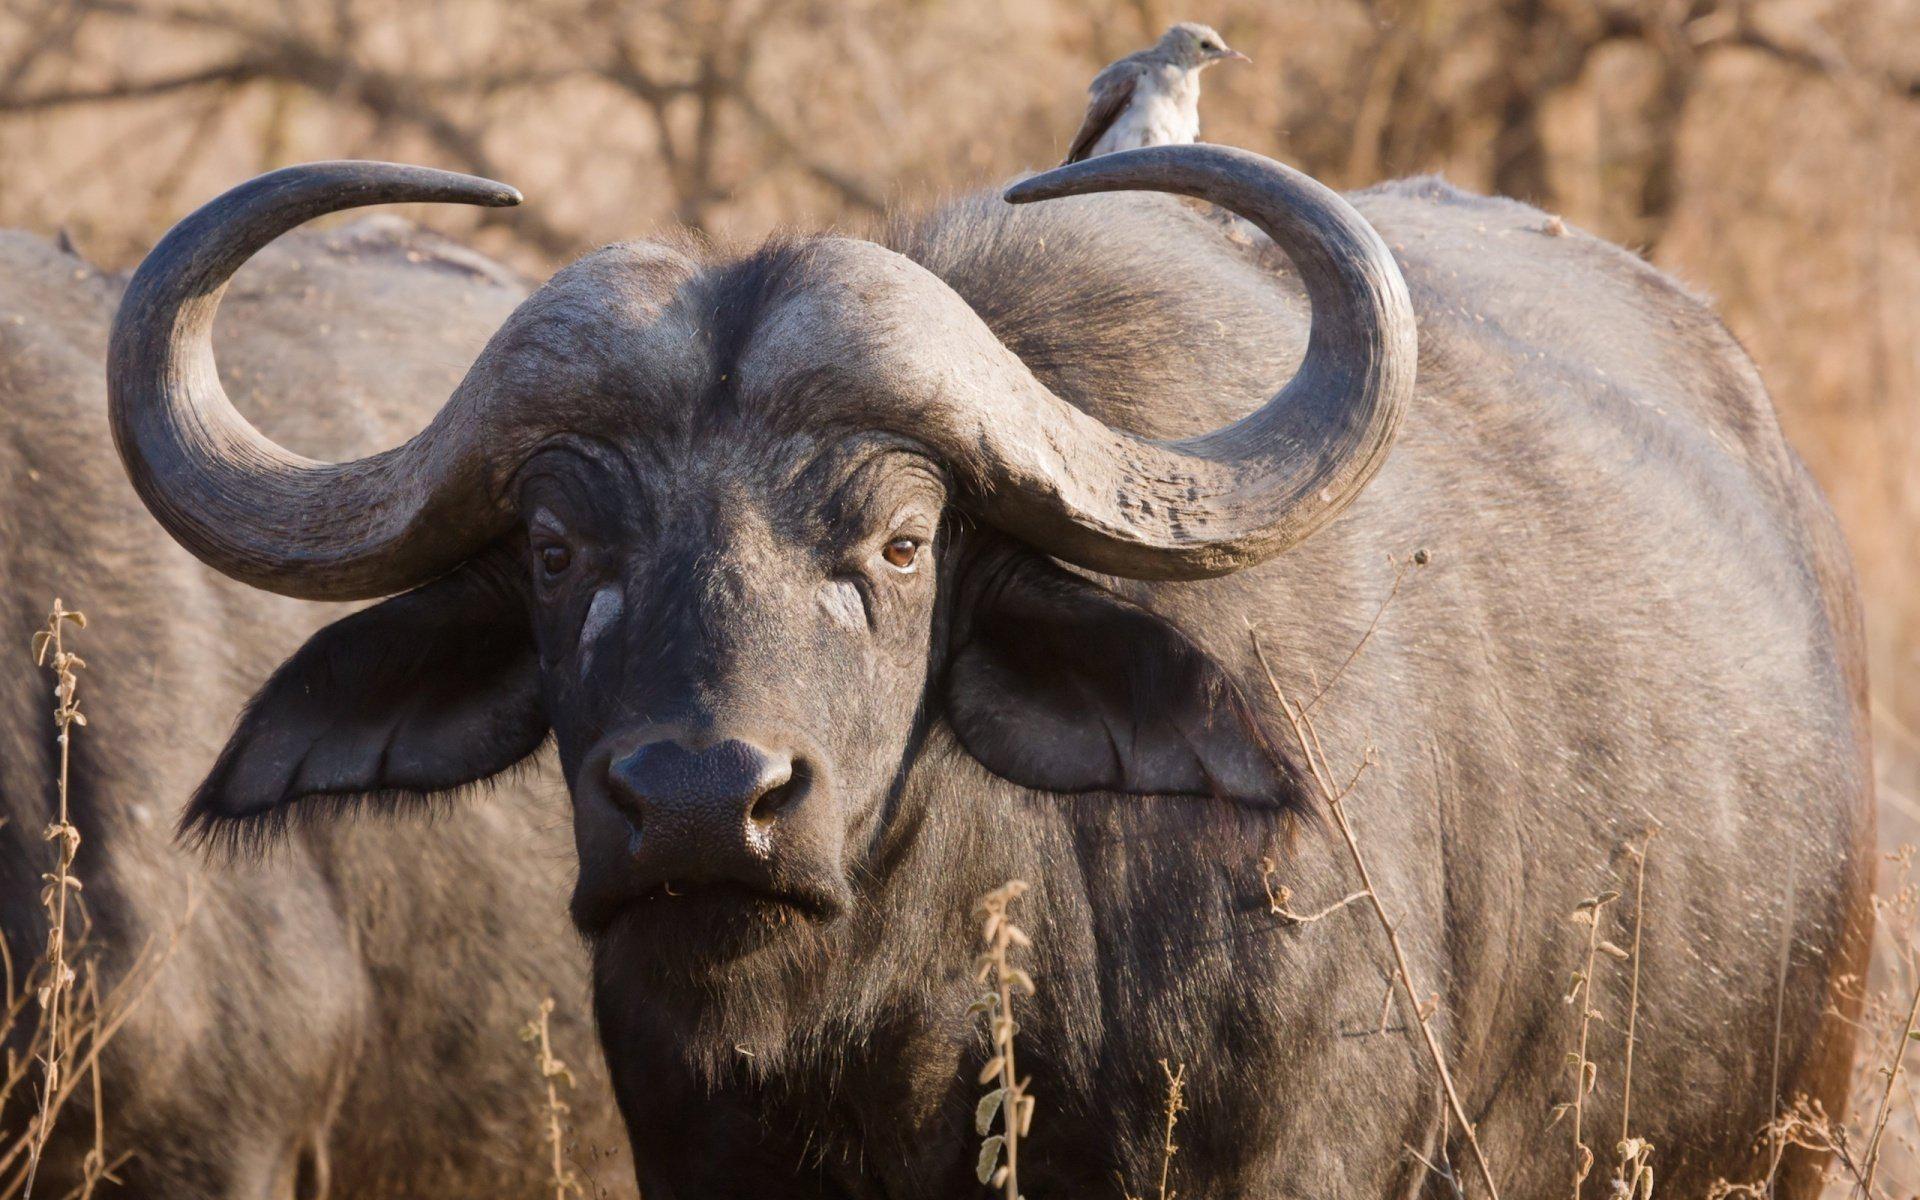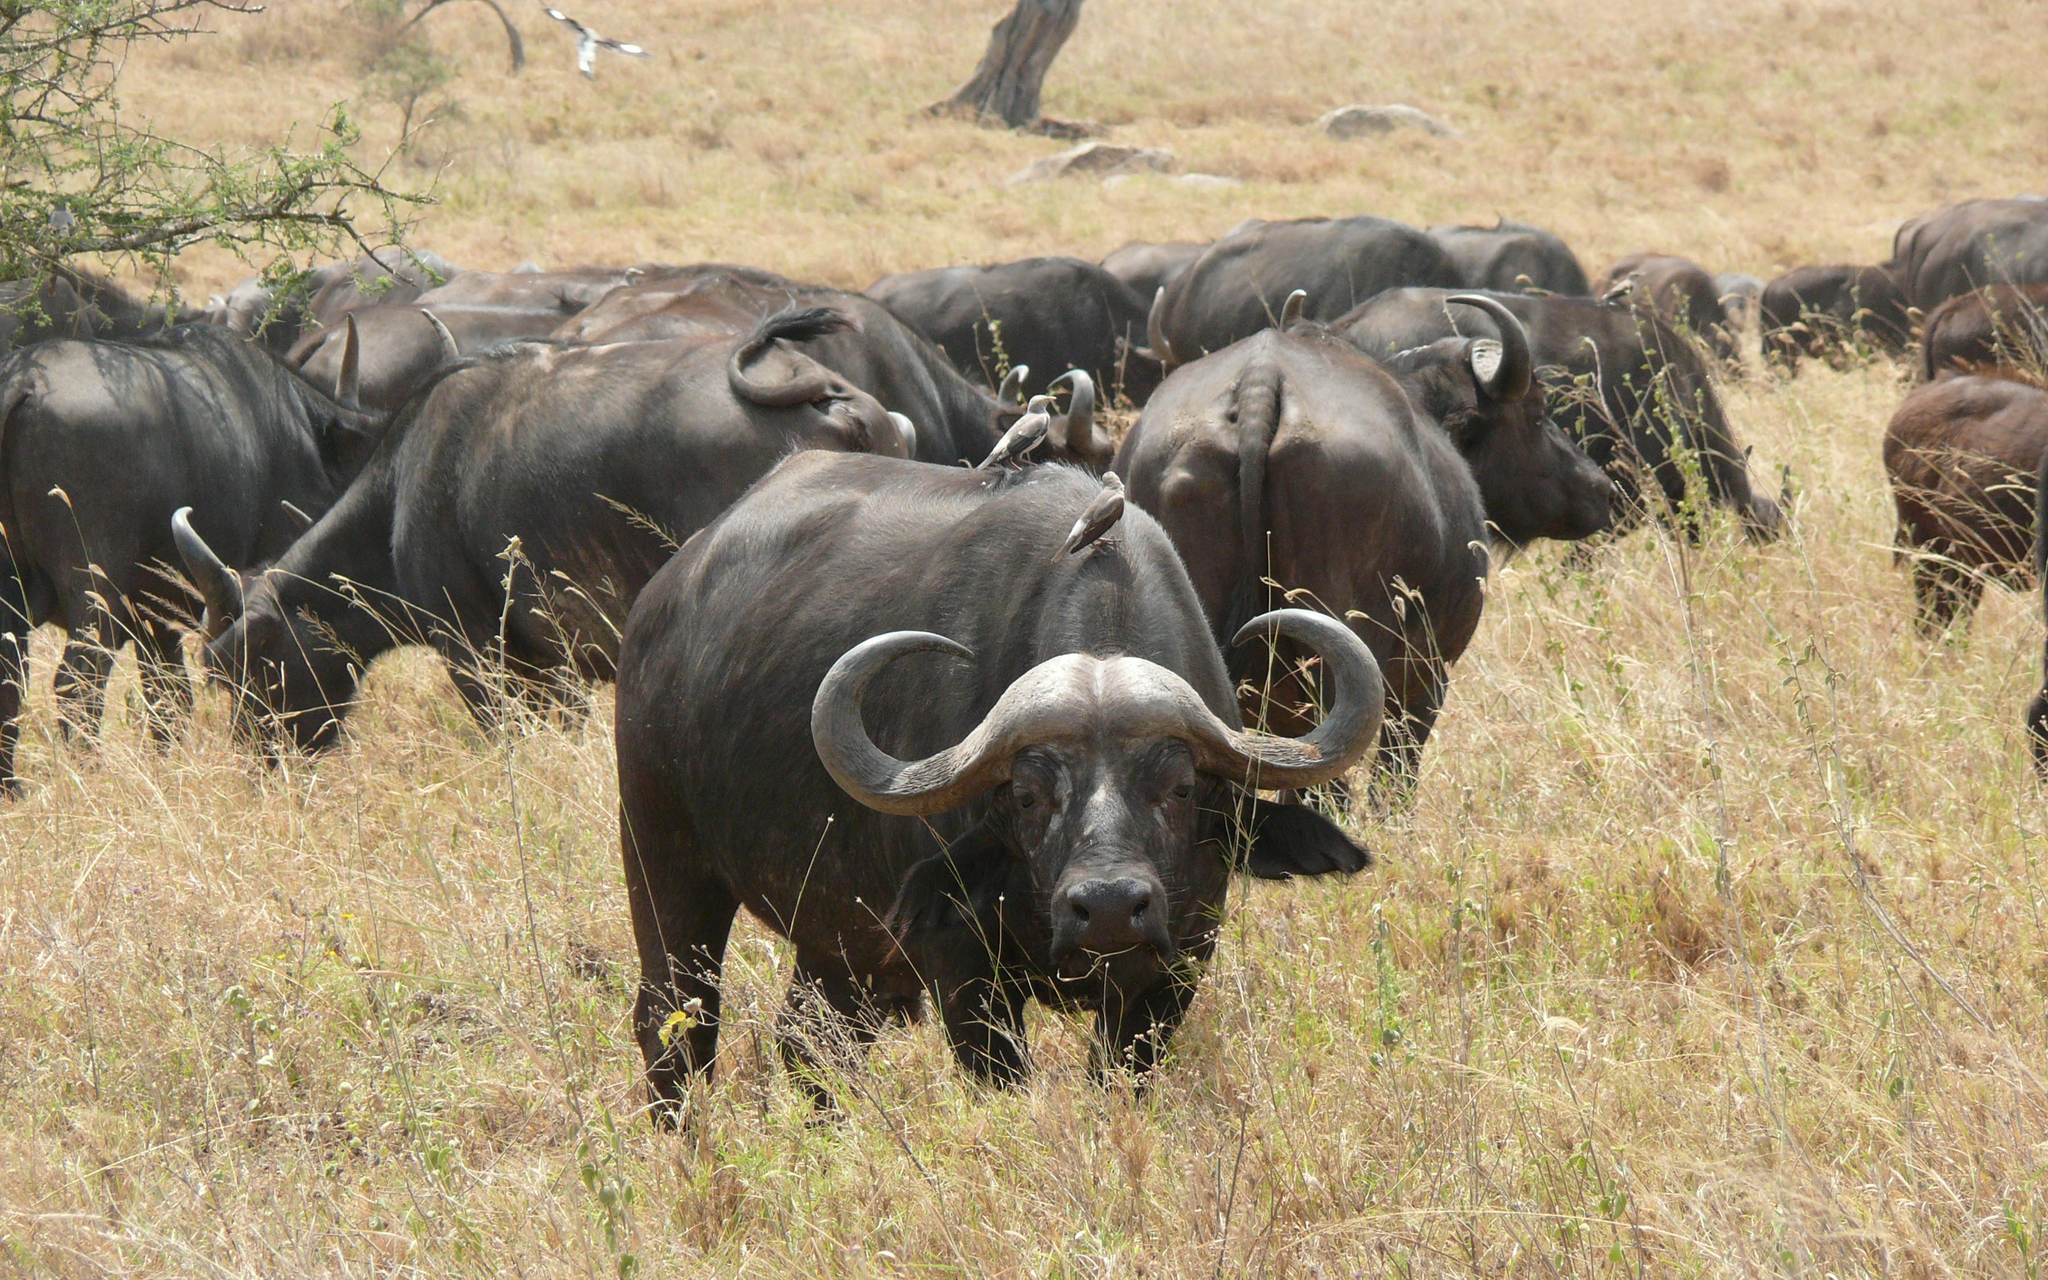The first image is the image on the left, the second image is the image on the right. Examine the images to the left and right. Is the description "There are at least two water buffalo's in the right image." accurate? Answer yes or no. Yes. 